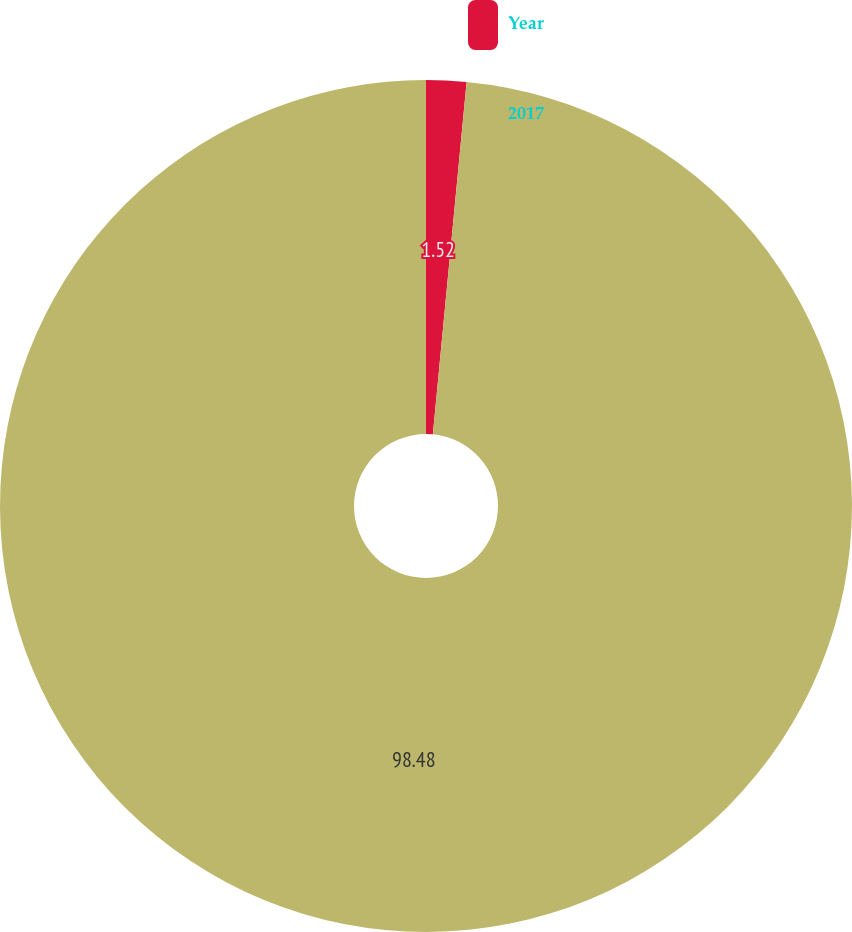Convert chart. <chart><loc_0><loc_0><loc_500><loc_500><pie_chart><fcel>Year<fcel>2017<nl><fcel>1.52%<fcel>98.48%<nl></chart> 